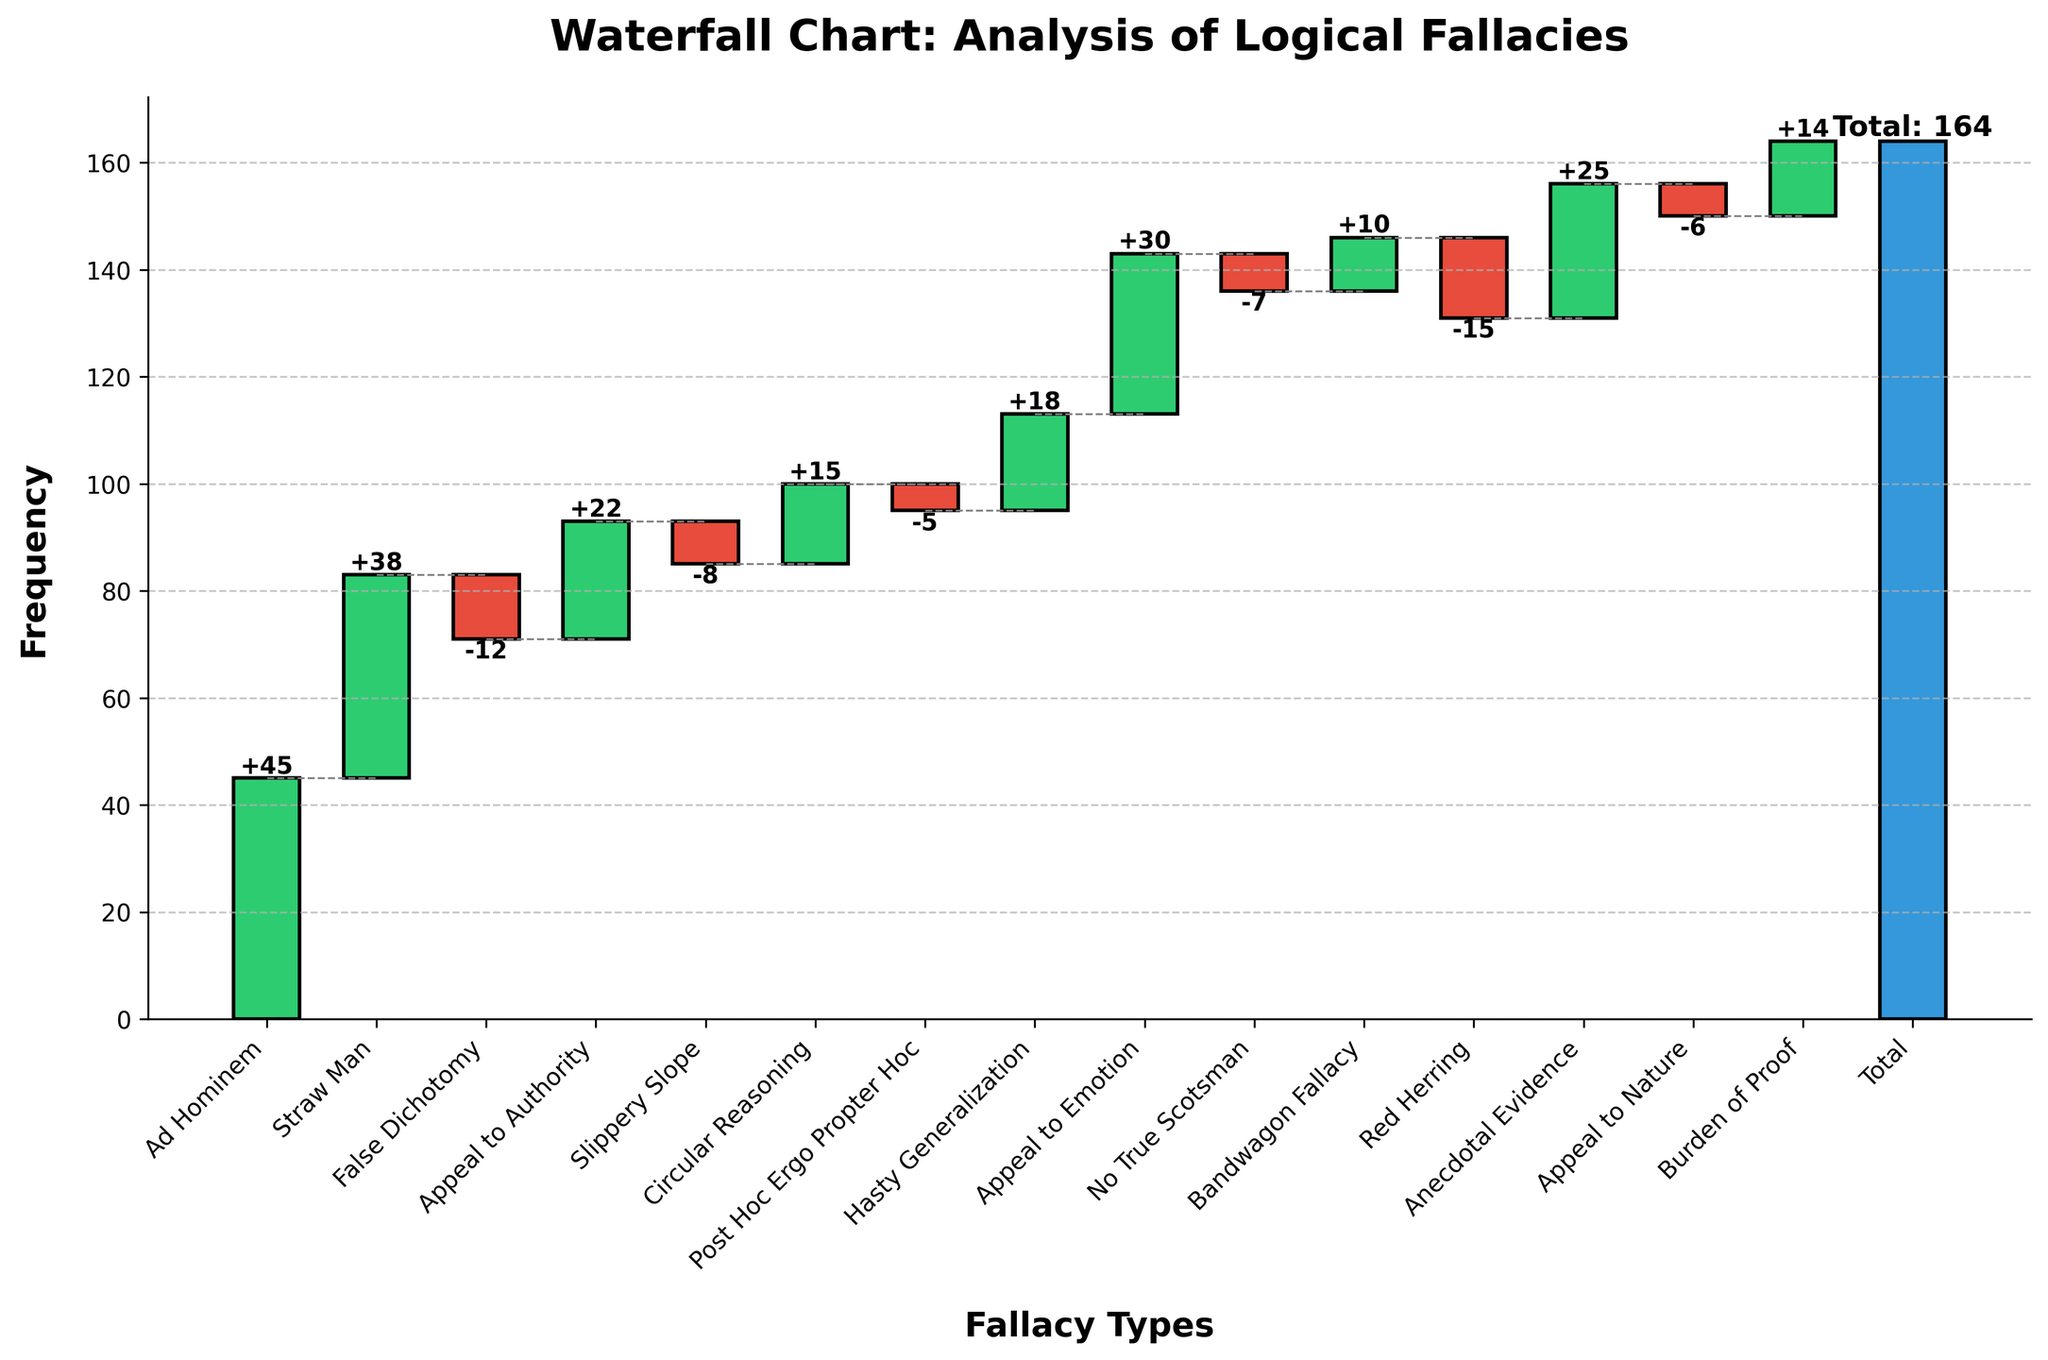What is the title of the chart? The title is located at the top of the chart. It reads "Waterfall Chart: Analysis of Logical Fallacies". This can be directly read from the image.
Answer: Waterfall Chart: Analysis of Logical Fallacies How many types of logical fallacies are analyzed in the chart? To find the types of logical fallacies, count the categories listed on the x-axis. The categories include: Ad Hominem, Straw Man, False Dichotomy, Appeal to Authority, Slippery Slope, Circular Reasoning, Post Hoc Ergo Propter Hoc, Hasty Generalization, Appeal to Emotion, No True Scotsman, Bandwagon Fallacy, Red Herring, Anecdotal Evidence, Appeal to Nature, Burden of Proof.
Answer: 15 Which fallacy has the highest frequency? Locate the tallest bar above the zero line. The category associated with this bar is the one with the highest frequency. From the chart, Ad Hominem appears to be the tallest bar.
Answer: Ad Hominem What is the cumulative total value of all fallacies? The cumulative value or total is explicitly shown as a bar at the end of the waterfall chart. Additionally, the numeric label on this bar states the total value.
Answer: 184 Which fallacies have negative values? Identify the bars that extend below the zero line. The corresponding categories are those with negative values. These fallacies are: False Dichotomy, Slippery Slope, Post Hoc Ergo Propter Hoc, No True Scotsman, Red Herring, and Appeal to Nature.
Answer: False Dichotomy, Slippery Slope, Post Hoc Ergo Propter Hoc, No True Scotsman, Red Herring, Appeal to Nature What is the sum of the values for all positive fallacies? Sum the values of fallacies with positive bars: Ad Hominem (45), Straw Man (38), Appeal to Authority (22), Circular Reasoning (15), Hasty Generalization (18), Appeal to Emotion (30), Bandwagon Fallacy (10), Anecdotal Evidence (25), Burden of Proof (14). Total sum = 217.
Answer: 217 How does the frequency of Appeal to Emotion compare to Bandwagon Fallacy? Find the heights of the bars corresponding to Appeal to Emotion and Bandwagon Fallacy. Appeal to Emotion has a value of 30 and Bandwagon Fallacy has a value of 10. Compare these values.
Answer: Appeal to Emotion is greater than Bandwagon Fallacy What is the average value of all fallacies? First, sum all the values: (45 + 38 - 12 + 22 - 8 + 15 - 5 + 18 + 30 - 7 + 10 - 15 + 25 - 6 + 14 = 184). Then, divide by the number of fallacies (15). Average = 184 / 15 ≈ 12.27.
Answer: 12.27 What two fallacies have values that sum to zero? Identify pairs of fallacies that, when added together, result in a sum of zero. From the list: Slippery Slope (-8) and Circular Reasoning (15 - 7); Post Hoc Ergo Propter Hoc (-5) and Appeal to Emotion (30 - 25). Hence, no pairs directly add up to zero without multiple combinations.
Answer: None What is the net effect of removing all negative values from the analysis? Sum only the negative values: False Dichotomy (-12), Slippery Slope (-8), Post Hoc Ergo Propter Hoc (-5), No True Scotsman (-7), Red Herring (-15), and Appeal to Nature (-6). Total negative value = -53. Net effect removes -53 from the original total of 184; therefore: 230 - 53 = 177.
Answer: 177 